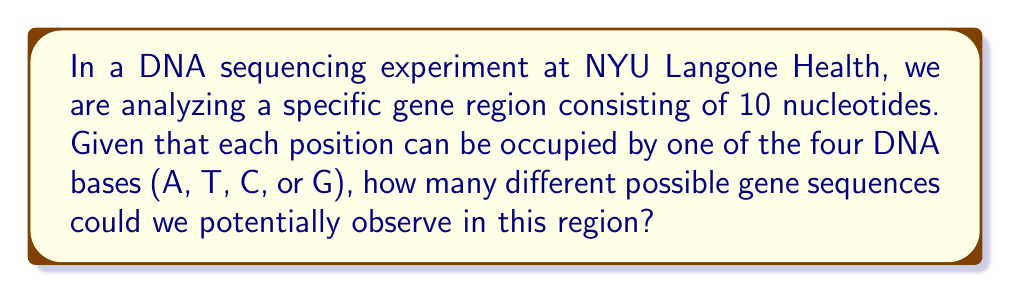Can you answer this question? Let's approach this step-by-step:

1) In DNA, there are four possible nucleotides at each position: Adenine (A), Thymine (T), Cytosine (C), and Guanine (G).

2) We are looking at a sequence of 10 nucleotides.

3) For each position, we have 4 choices, and this is independent of the choices for other positions.

4) This scenario follows the multiplication principle of counting.

5) The total number of possibilities is therefore:

   $$ 4 \times 4 \times 4 \times 4 \times 4 \times 4 \times 4 \times 4 \times 4 \times 4 $$

6) This can be written more concisely as:

   $$ 4^{10} $$

7) To calculate:

   $$ 4^{10} = 1,048,576 $$

Therefore, there are 1,048,576 possible gene sequences in this 10-nucleotide region.
Answer: $4^{10} = 1,048,576$ 